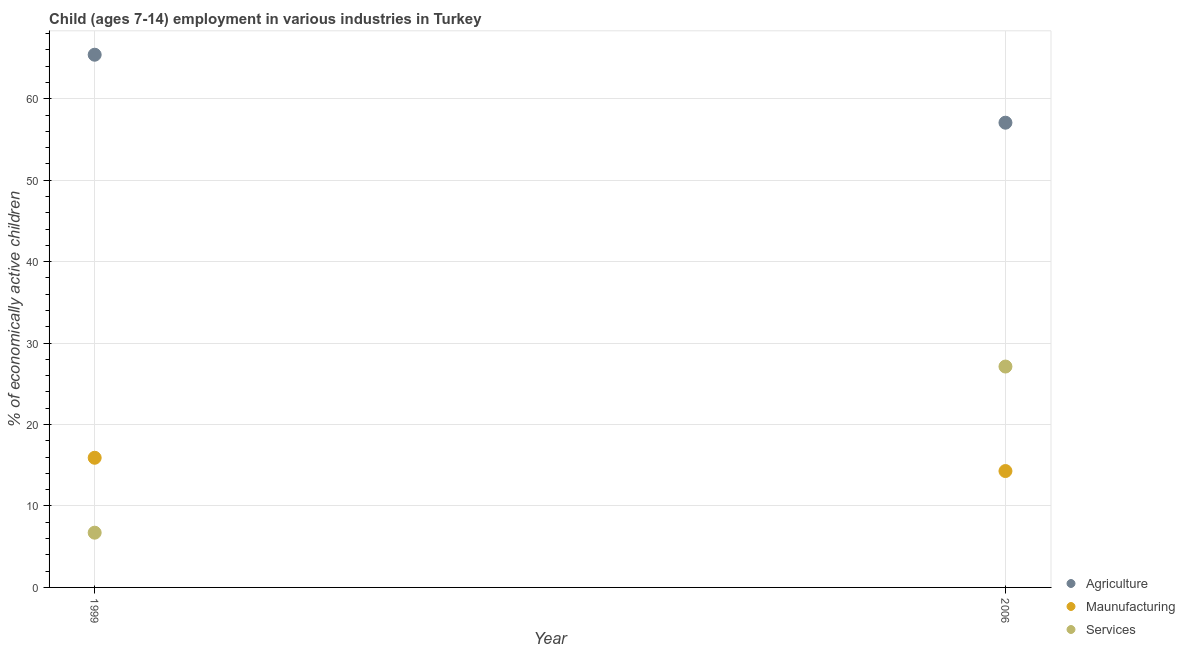How many different coloured dotlines are there?
Make the answer very short. 3. Is the number of dotlines equal to the number of legend labels?
Give a very brief answer. Yes. What is the percentage of economically active children in manufacturing in 2006?
Your response must be concise. 14.29. Across all years, what is the maximum percentage of economically active children in agriculture?
Your response must be concise. 65.41. Across all years, what is the minimum percentage of economically active children in agriculture?
Make the answer very short. 57.06. What is the total percentage of economically active children in agriculture in the graph?
Your answer should be very brief. 122.47. What is the difference between the percentage of economically active children in manufacturing in 1999 and that in 2006?
Ensure brevity in your answer.  1.63. What is the difference between the percentage of economically active children in services in 2006 and the percentage of economically active children in manufacturing in 1999?
Your answer should be very brief. 11.2. What is the average percentage of economically active children in services per year?
Make the answer very short. 16.92. In the year 1999, what is the difference between the percentage of economically active children in agriculture and percentage of economically active children in services?
Offer a terse response. 58.68. In how many years, is the percentage of economically active children in agriculture greater than 40 %?
Keep it short and to the point. 2. What is the ratio of the percentage of economically active children in manufacturing in 1999 to that in 2006?
Keep it short and to the point. 1.11. Is the percentage of economically active children in agriculture strictly greater than the percentage of economically active children in manufacturing over the years?
Ensure brevity in your answer.  Yes. Is the percentage of economically active children in manufacturing strictly less than the percentage of economically active children in agriculture over the years?
Provide a short and direct response. Yes. How many years are there in the graph?
Your answer should be compact. 2. Where does the legend appear in the graph?
Make the answer very short. Bottom right. How many legend labels are there?
Provide a succinct answer. 3. How are the legend labels stacked?
Your answer should be very brief. Vertical. What is the title of the graph?
Offer a very short reply. Child (ages 7-14) employment in various industries in Turkey. Does "Labor Market" appear as one of the legend labels in the graph?
Offer a terse response. No. What is the label or title of the X-axis?
Make the answer very short. Year. What is the label or title of the Y-axis?
Provide a short and direct response. % of economically active children. What is the % of economically active children of Agriculture in 1999?
Offer a terse response. 65.41. What is the % of economically active children of Maunufacturing in 1999?
Keep it short and to the point. 15.92. What is the % of economically active children in Services in 1999?
Keep it short and to the point. 6.72. What is the % of economically active children in Agriculture in 2006?
Ensure brevity in your answer.  57.06. What is the % of economically active children of Maunufacturing in 2006?
Provide a short and direct response. 14.29. What is the % of economically active children in Services in 2006?
Ensure brevity in your answer.  27.12. Across all years, what is the maximum % of economically active children in Agriculture?
Offer a terse response. 65.41. Across all years, what is the maximum % of economically active children of Maunufacturing?
Offer a terse response. 15.92. Across all years, what is the maximum % of economically active children in Services?
Provide a short and direct response. 27.12. Across all years, what is the minimum % of economically active children of Agriculture?
Provide a succinct answer. 57.06. Across all years, what is the minimum % of economically active children of Maunufacturing?
Your response must be concise. 14.29. Across all years, what is the minimum % of economically active children of Services?
Provide a succinct answer. 6.72. What is the total % of economically active children of Agriculture in the graph?
Give a very brief answer. 122.47. What is the total % of economically active children of Maunufacturing in the graph?
Ensure brevity in your answer.  30.21. What is the total % of economically active children of Services in the graph?
Give a very brief answer. 33.84. What is the difference between the % of economically active children of Agriculture in 1999 and that in 2006?
Your response must be concise. 8.35. What is the difference between the % of economically active children in Maunufacturing in 1999 and that in 2006?
Provide a short and direct response. 1.63. What is the difference between the % of economically active children in Services in 1999 and that in 2006?
Provide a succinct answer. -20.4. What is the difference between the % of economically active children of Agriculture in 1999 and the % of economically active children of Maunufacturing in 2006?
Make the answer very short. 51.12. What is the difference between the % of economically active children of Agriculture in 1999 and the % of economically active children of Services in 2006?
Provide a succinct answer. 38.29. What is the difference between the % of economically active children in Maunufacturing in 1999 and the % of economically active children in Services in 2006?
Make the answer very short. -11.2. What is the average % of economically active children in Agriculture per year?
Offer a very short reply. 61.23. What is the average % of economically active children in Maunufacturing per year?
Keep it short and to the point. 15.1. What is the average % of economically active children in Services per year?
Give a very brief answer. 16.92. In the year 1999, what is the difference between the % of economically active children of Agriculture and % of economically active children of Maunufacturing?
Your answer should be very brief. 49.49. In the year 1999, what is the difference between the % of economically active children in Agriculture and % of economically active children in Services?
Make the answer very short. 58.68. In the year 1999, what is the difference between the % of economically active children in Maunufacturing and % of economically active children in Services?
Give a very brief answer. 9.2. In the year 2006, what is the difference between the % of economically active children of Agriculture and % of economically active children of Maunufacturing?
Your answer should be compact. 42.77. In the year 2006, what is the difference between the % of economically active children in Agriculture and % of economically active children in Services?
Provide a short and direct response. 29.94. In the year 2006, what is the difference between the % of economically active children in Maunufacturing and % of economically active children in Services?
Offer a terse response. -12.83. What is the ratio of the % of economically active children of Agriculture in 1999 to that in 2006?
Offer a terse response. 1.15. What is the ratio of the % of economically active children in Maunufacturing in 1999 to that in 2006?
Give a very brief answer. 1.11. What is the ratio of the % of economically active children of Services in 1999 to that in 2006?
Make the answer very short. 0.25. What is the difference between the highest and the second highest % of economically active children of Agriculture?
Keep it short and to the point. 8.35. What is the difference between the highest and the second highest % of economically active children of Maunufacturing?
Ensure brevity in your answer.  1.63. What is the difference between the highest and the second highest % of economically active children in Services?
Your answer should be very brief. 20.4. What is the difference between the highest and the lowest % of economically active children of Agriculture?
Offer a terse response. 8.35. What is the difference between the highest and the lowest % of economically active children of Maunufacturing?
Make the answer very short. 1.63. What is the difference between the highest and the lowest % of economically active children of Services?
Offer a terse response. 20.4. 